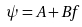<formula> <loc_0><loc_0><loc_500><loc_500>\psi = A + B f</formula> 